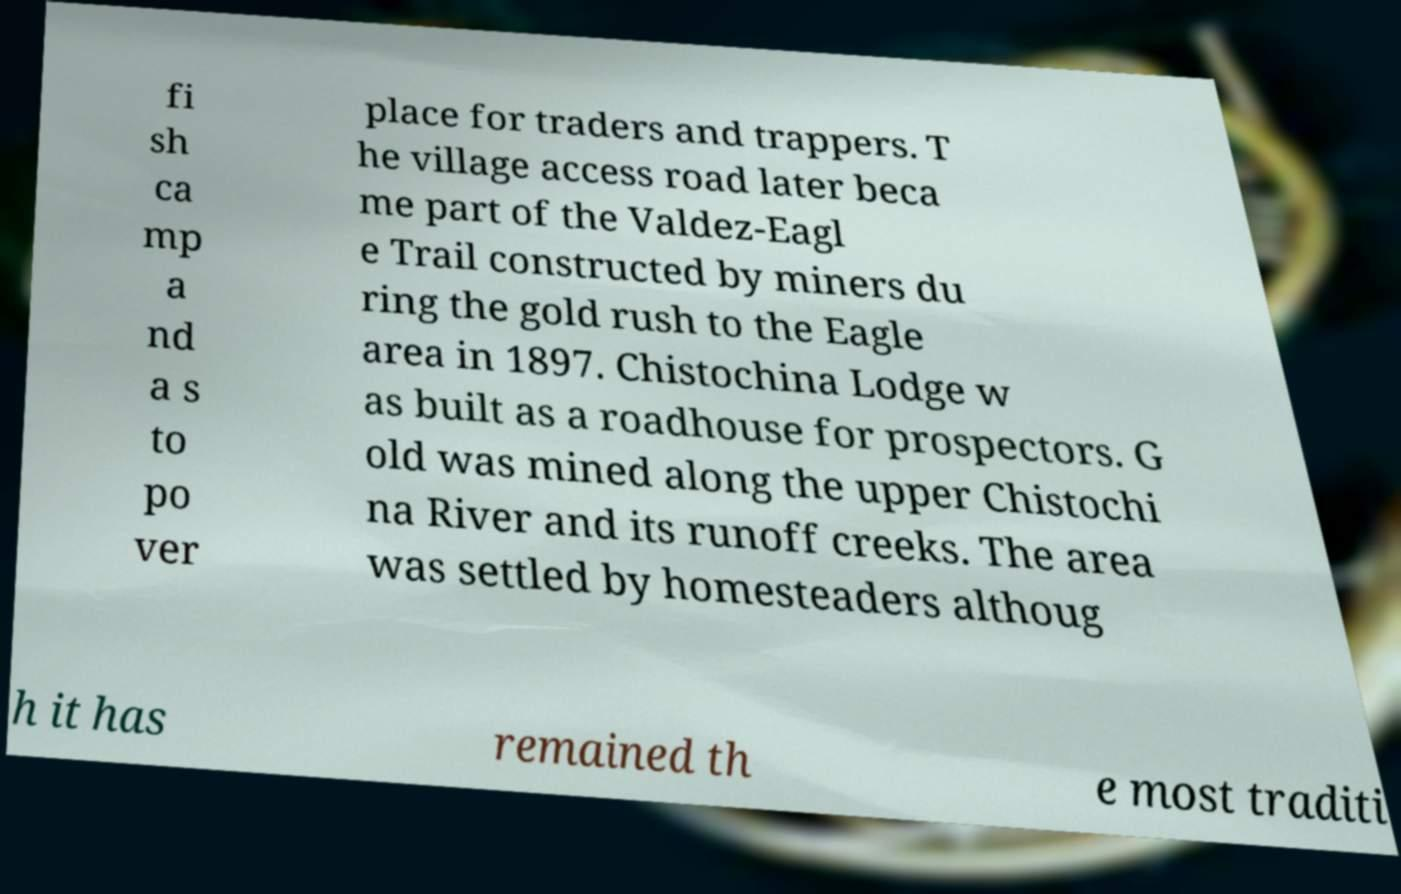For documentation purposes, I need the text within this image transcribed. Could you provide that? fi sh ca mp a nd a s to po ver place for traders and trappers. T he village access road later beca me part of the Valdez-Eagl e Trail constructed by miners du ring the gold rush to the Eagle area in 1897. Chistochina Lodge w as built as a roadhouse for prospectors. G old was mined along the upper Chistochi na River and its runoff creeks. The area was settled by homesteaders althoug h it has remained th e most traditi 